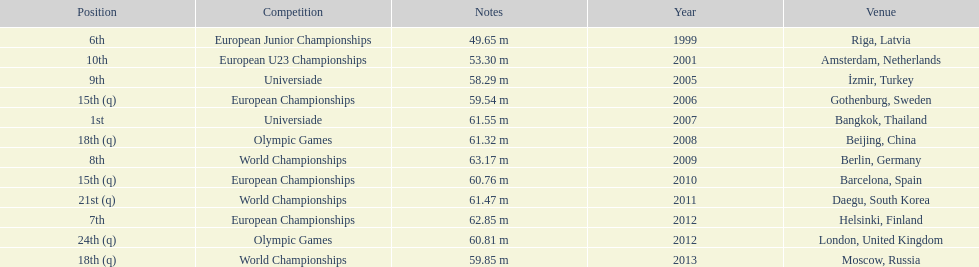What are all the competitions? European Junior Championships, European U23 Championships, Universiade, European Championships, Universiade, Olympic Games, World Championships, European Championships, World Championships, European Championships, Olympic Games, World Championships. What years did they place in the top 10? 1999, 2001, 2005, 2007, 2009, 2012. Besides when they placed first, which position was their highest? 6th. Write the full table. {'header': ['Position', 'Competition', 'Notes', 'Year', 'Venue'], 'rows': [['6th', 'European Junior Championships', '49.65 m', '1999', 'Riga, Latvia'], ['10th', 'European U23 Championships', '53.30 m', '2001', 'Amsterdam, Netherlands'], ['9th', 'Universiade', '58.29 m', '2005', 'İzmir, Turkey'], ['15th (q)', 'European Championships', '59.54 m', '2006', 'Gothenburg, Sweden'], ['1st', 'Universiade', '61.55 m', '2007', 'Bangkok, Thailand'], ['18th (q)', 'Olympic Games', '61.32 m', '2008', 'Beijing, China'], ['8th', 'World Championships', '63.17 m', '2009', 'Berlin, Germany'], ['15th (q)', 'European Championships', '60.76 m', '2010', 'Barcelona, Spain'], ['21st (q)', 'World Championships', '61.47 m', '2011', 'Daegu, South Korea'], ['7th', 'European Championships', '62.85 m', '2012', 'Helsinki, Finland'], ['24th (q)', 'Olympic Games', '60.81 m', '2012', 'London, United Kingdom'], ['18th (q)', 'World Championships', '59.85 m', '2013', 'Moscow, Russia']]} 